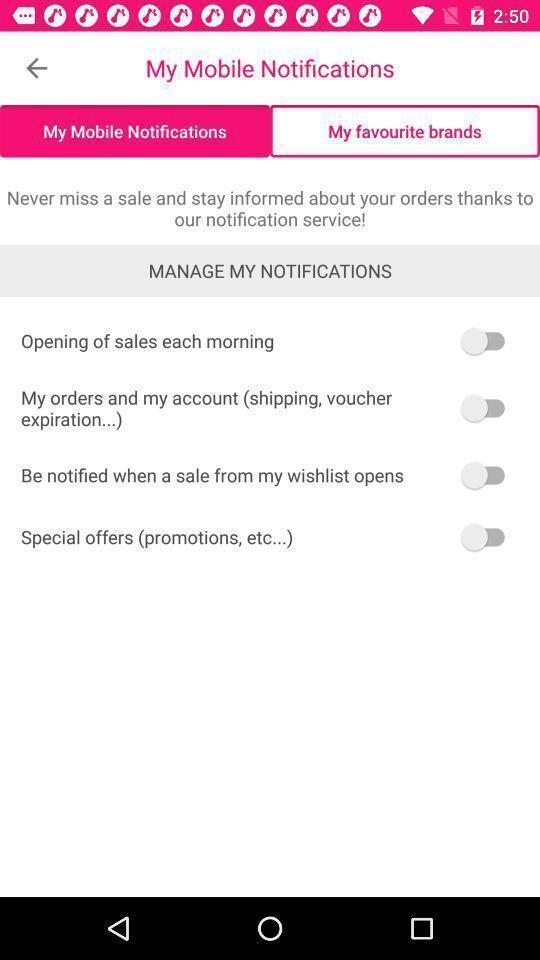Summarize the main components in this picture. Screen shows manage mobile notifications. 